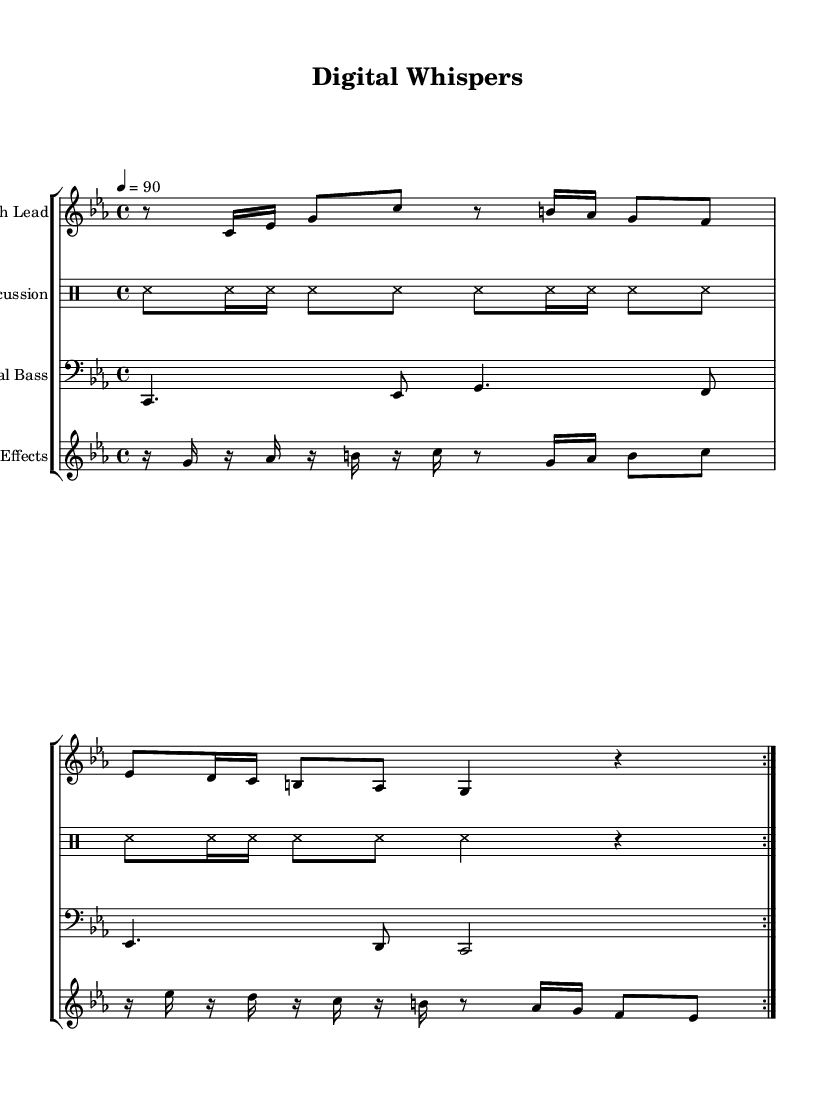What is the key signature of this music? The key signature is C minor, which has three flats (B♭, E♭, and A♭).
Answer: C minor What is the time signature of this music? The time signature is 4/4, which means there are four beats in each measure.
Answer: 4/4 What is the tempo marking of this piece? The tempo marking is 90 beats per minute, indicating a moderate speed for the composition.
Answer: 90 How many measures are in the glitch lead section? The glitch lead section features 8 measures, as indicated by the repeated structure in the notation.
Answer: 8 measures Which instrument plays the ASMR percussion? The ASMR percussion is played on a drum staff as indicated in the score, specifically designed for soft sounds.
Answer: Drum staff How is the structure of the glitch effects section defined? The glitch effects section consists of repeated patterns that employ rests, indicating a focus on rhythm and space within the composition.
Answer: Repeated patterns Which type of beats does the binaural bass section use? The binaural bass section uses dotted quarter notes and eighth notes, providing a thick, immersive sound characteristic of glitch-hop.
Answer: Dotted quarter notes 